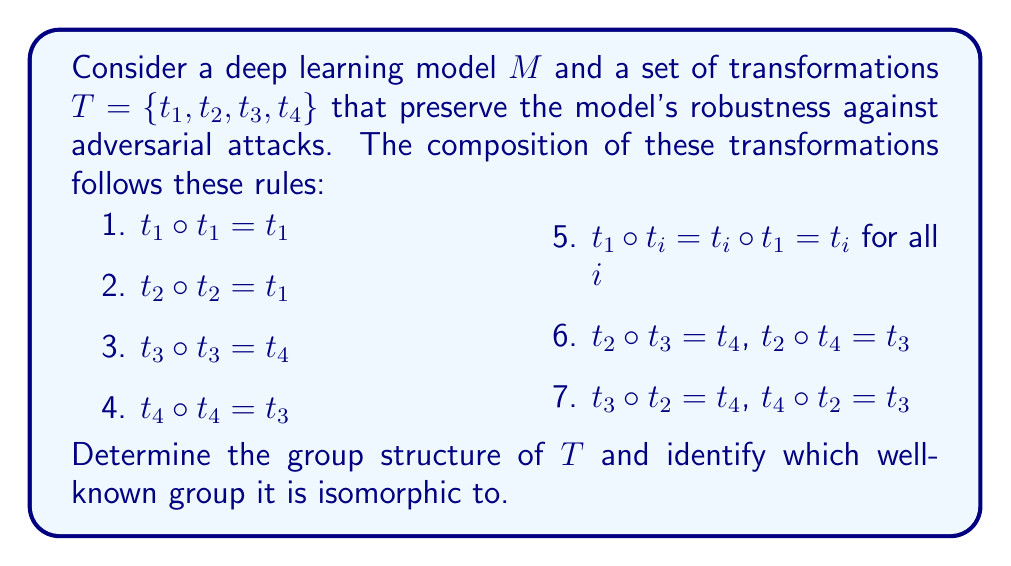Can you solve this math problem? Let's approach this step-by-step:

1) First, we need to verify that $T$ is indeed a group:
   - Closure: The composition of any two elements in $T$ results in an element in $T$ (given by the rules).
   - Associativity: Composition of functions is always associative.
   - Identity: $t_1$ acts as the identity element (rule 5).
   - Inverse: $t_1$ is its own inverse, $t_2$ is its own inverse, $t_3$ and $t_4$ are inverses of each other.

2) Now, let's construct the group table:

   $$\begin{array}{c|cccc}
   \circ & t_1 & t_2 & t_3 & t_4 \\
   \hline
   t_1 & t_1 & t_2 & t_3 & t_4 \\
   t_2 & t_2 & t_1 & t_4 & t_3 \\
   t_3 & t_3 & t_4 & t_4 & t_3 \\
   t_4 & t_4 & t_3 & t_3 & t_4
   \end{array}$$

3) Analyzing the structure:
   - The group has order 4.
   - It has one element of order 1 ($t_1$), one element of order 2 ($t_2$), and two elements of order 4 ($t_3$ and $t_4$).
   - It is non-abelian, as $t_2 \circ t_3 \neq t_3 \circ t_2$.

4) These properties uniquely identify this group as isomorphic to the dihedral group of order 4, denoted $D_4$ or $D_2$.

5) In terms of symmetries, we can interpret:
   - $t_1$ as the identity transformation
   - $t_2$ as a 180° rotation or reflection
   - $t_3$ and $t_4$ as 90° rotations in opposite directions

This group structure implies that the robustness-preserving transformations for the model $M$ behave like the symmetries of a square, which is a significant insight for understanding the model's invariance properties.
Answer: The group $T$ is isomorphic to $D_4$ (dihedral group of order 4). 